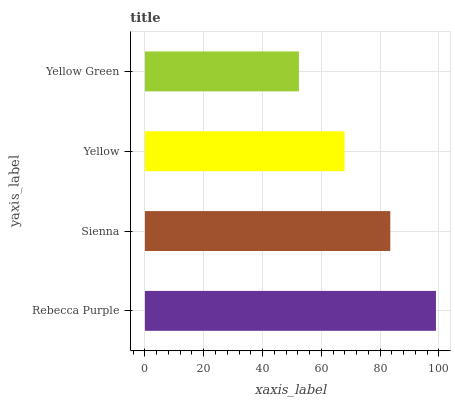Is Yellow Green the minimum?
Answer yes or no. Yes. Is Rebecca Purple the maximum?
Answer yes or no. Yes. Is Sienna the minimum?
Answer yes or no. No. Is Sienna the maximum?
Answer yes or no. No. Is Rebecca Purple greater than Sienna?
Answer yes or no. Yes. Is Sienna less than Rebecca Purple?
Answer yes or no. Yes. Is Sienna greater than Rebecca Purple?
Answer yes or no. No. Is Rebecca Purple less than Sienna?
Answer yes or no. No. Is Sienna the high median?
Answer yes or no. Yes. Is Yellow the low median?
Answer yes or no. Yes. Is Yellow Green the high median?
Answer yes or no. No. Is Sienna the low median?
Answer yes or no. No. 